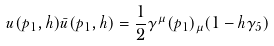Convert formula to latex. <formula><loc_0><loc_0><loc_500><loc_500>u ( p _ { 1 } , h ) \bar { u } ( p _ { 1 } , h ) = \frac { 1 } { 2 } \gamma ^ { \mu } ( p _ { 1 } ) _ { \mu } ( 1 - h \gamma _ { 5 } )</formula> 